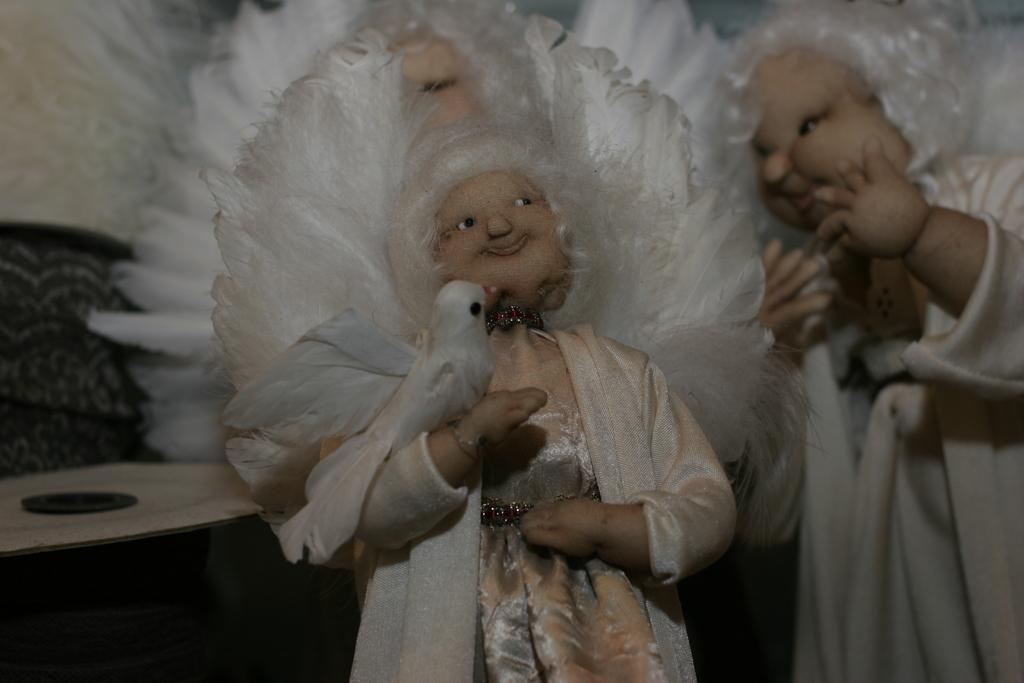What type of objects can be seen in the image? There are toys in the image. Can you describe the placement of one of the objects in the image? There is an object on a wooden plank in the image. What type of legal advice is the toy lawyer providing in the image? There is no toy lawyer present in the image, and therefore no legal advice can be observed. 